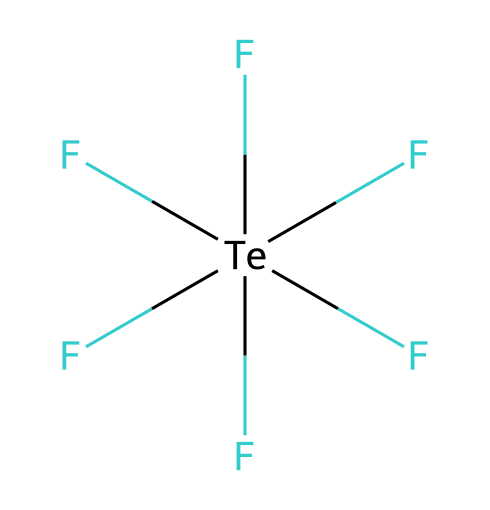What is the central atom of tellurium hexafluoride? The SMILES representation indicates that tellurium is the central atom as it is the one bonded to multiple fluorine atoms, reflecting its position in the structure.
Answer: tellurium How many fluorine atoms are bonded to tellurium? By observing the SMILES, there are six fluorine atoms indicated by the six ‘F’ groups connected to the tellurium atom.
Answer: six What type of compound is tellurium hexafluoride? The presence of more bonds to the central atom than the typical valence suggest that it is hypervalent with a central atom bonded to more than four atoms.
Answer: hypervalent What is the total number of bonds in tellurium hexafluoride? Each fluorine atom forms a single bond with the tellurium atom, resulting in a total of six bonds combining the central atom and the fluorines.
Answer: six Is tellurium hexafluoride a polar or nonpolar molecule? The symmetrical arrangement of six identical fluorine atoms around the central tellurium results in a nonpolar geometry with no net dipole moment.
Answer: nonpolar What is the coordination number of the tellurium atom in this compound? The coordination number is defined by the number of atoms directly bonded to the central atom; here, there are six fluorine atoms bonded to tellurium.
Answer: six 